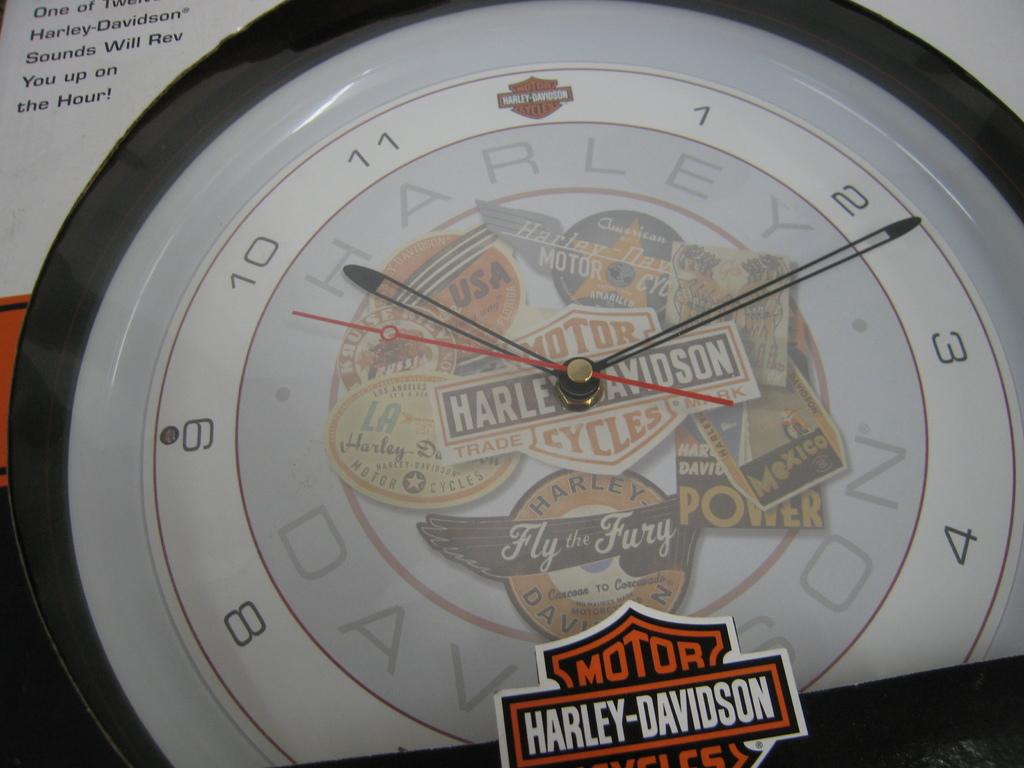What type of watch is thiss?
Ensure brevity in your answer.  Harley davidson. 